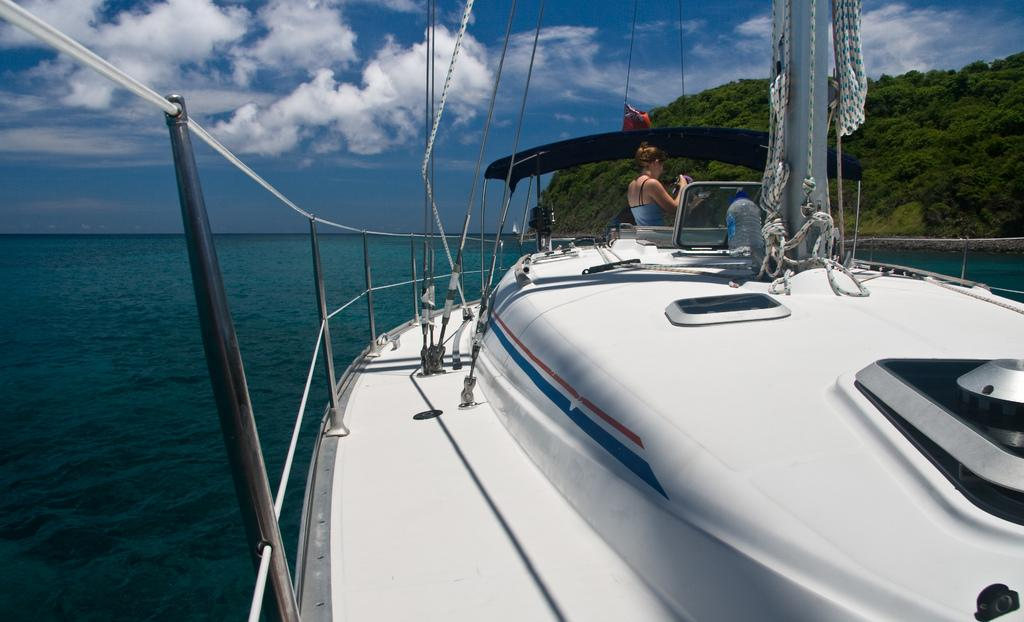What is the main subject of the image? There is a ship in the image. Can you describe the woman's position in relation to the ship? A woman is standing in front of the ship. What is the ship doing in the image? The ship is sailing in the water. What can be seen beside the water in the image? There is a mountain covered with greenery beside the water. What type of frog can be seen performing an operation on the ship in the image? There is no frog or operation present in the image; it features a ship sailing in the water with a woman standing in front of it. Can you tell me how many drains are visible on the ship in the image? There is no mention of drains on the ship in the image; it only shows a ship sailing in the water. 